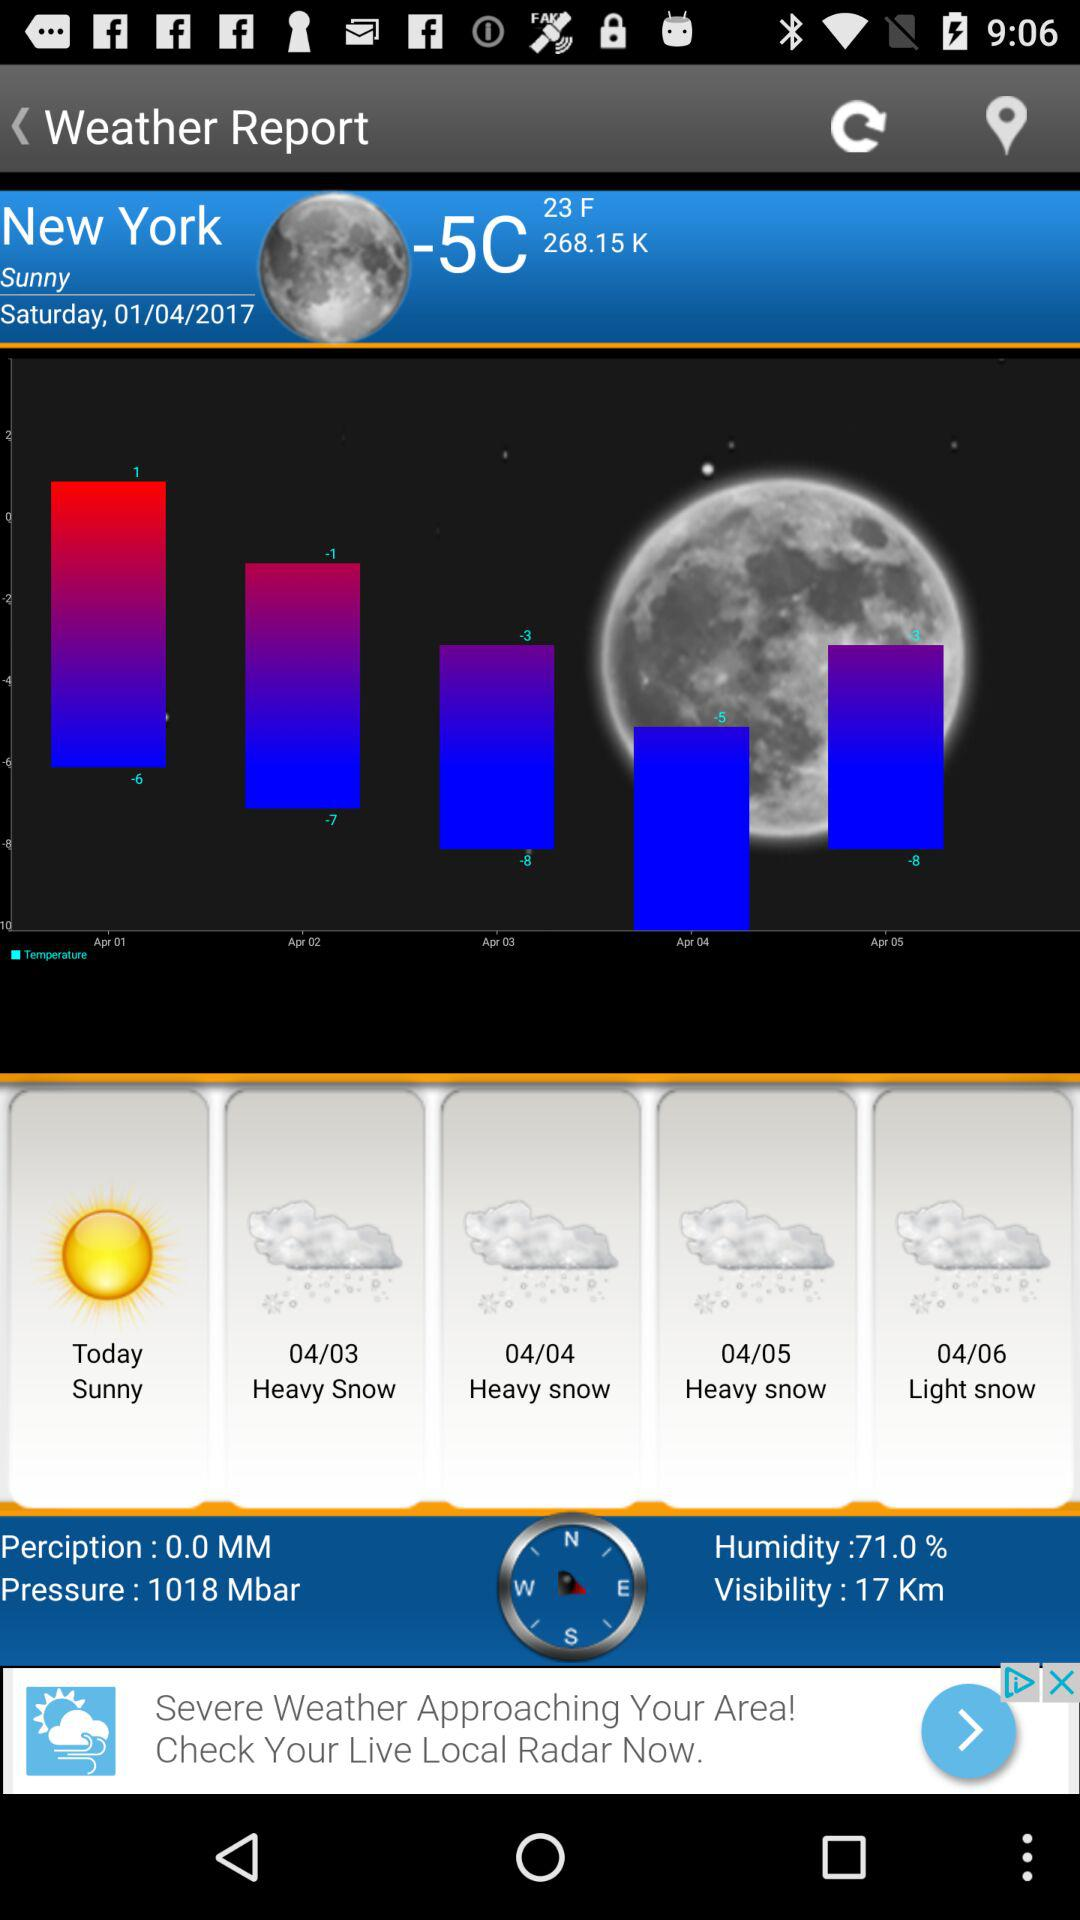How many days are there in the forecast?
Answer the question using a single word or phrase. 5 